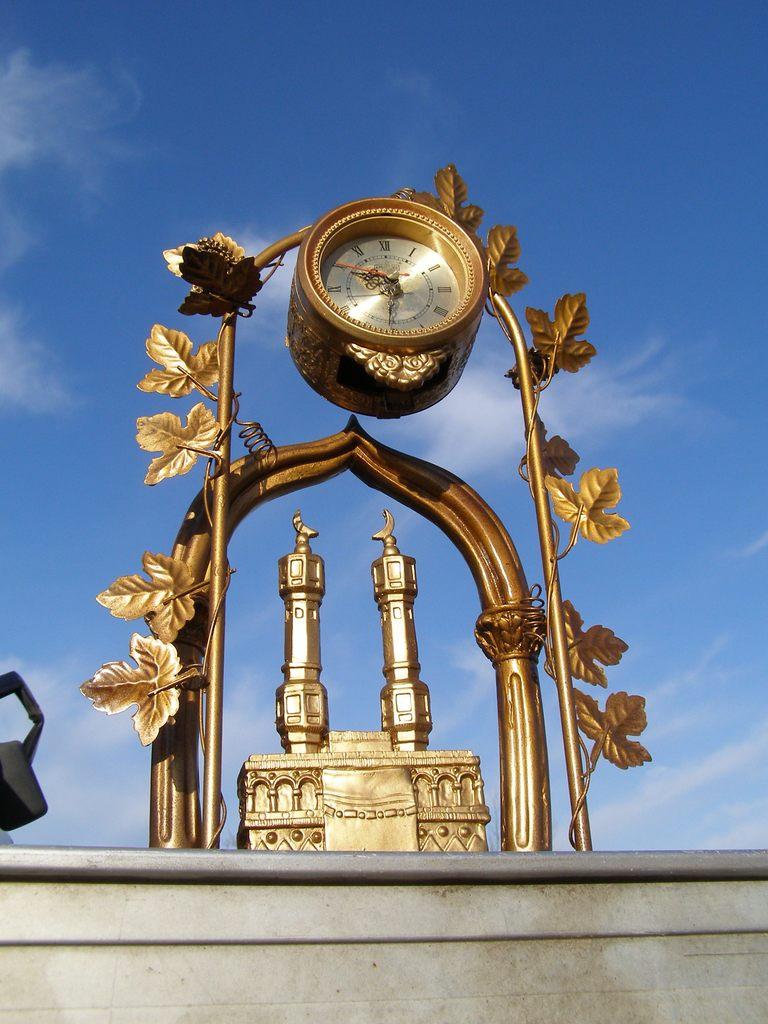What time does the clock read?
Your answer should be very brief. 9:31. 